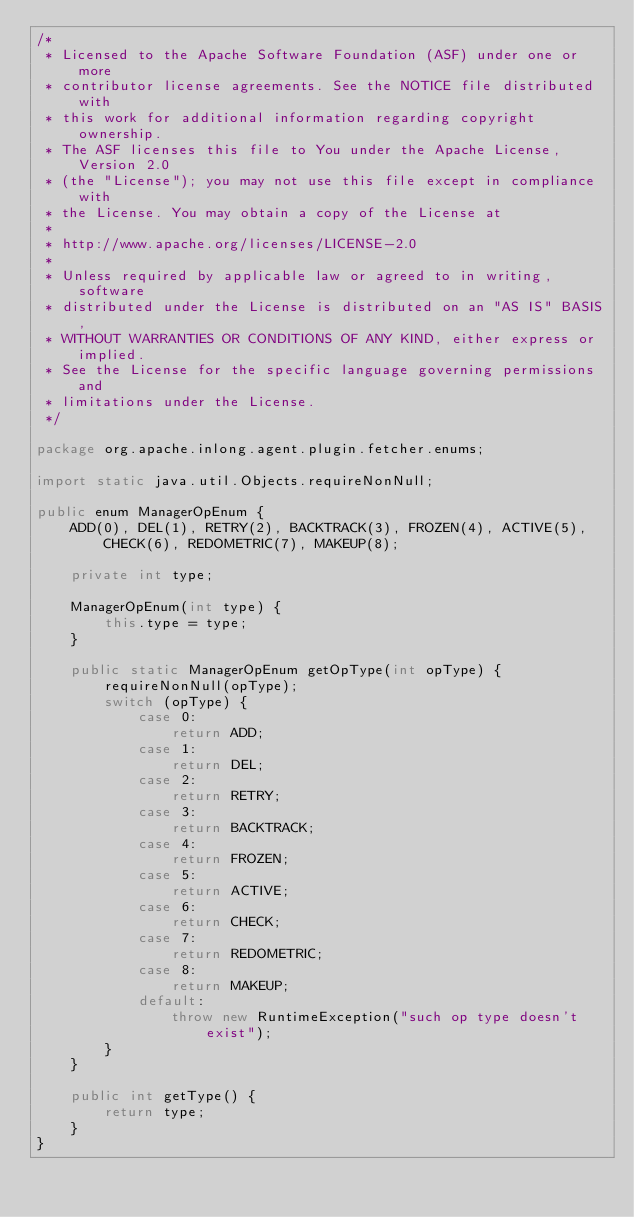Convert code to text. <code><loc_0><loc_0><loc_500><loc_500><_Java_>/*
 * Licensed to the Apache Software Foundation (ASF) under one or more
 * contributor license agreements. See the NOTICE file distributed with
 * this work for additional information regarding copyright ownership.
 * The ASF licenses this file to You under the Apache License, Version 2.0
 * (the "License"); you may not use this file except in compliance with
 * the License. You may obtain a copy of the License at
 *
 * http://www.apache.org/licenses/LICENSE-2.0
 *
 * Unless required by applicable law or agreed to in writing, software
 * distributed under the License is distributed on an "AS IS" BASIS,
 * WITHOUT WARRANTIES OR CONDITIONS OF ANY KIND, either express or implied.
 * See the License for the specific language governing permissions and
 * limitations under the License.
 */

package org.apache.inlong.agent.plugin.fetcher.enums;

import static java.util.Objects.requireNonNull;

public enum ManagerOpEnum {
    ADD(0), DEL(1), RETRY(2), BACKTRACK(3), FROZEN(4), ACTIVE(5), CHECK(6), REDOMETRIC(7), MAKEUP(8);

    private int type;

    ManagerOpEnum(int type) {
        this.type = type;
    }

    public static ManagerOpEnum getOpType(int opType) {
        requireNonNull(opType);
        switch (opType) {
            case 0:
                return ADD;
            case 1:
                return DEL;
            case 2:
                return RETRY;
            case 3:
                return BACKTRACK;
            case 4:
                return FROZEN;
            case 5:
                return ACTIVE;
            case 6:
                return CHECK;
            case 7:
                return REDOMETRIC;
            case 8:
                return MAKEUP;
            default:
                throw new RuntimeException("such op type doesn't exist");
        }
    }

    public int getType() {
        return type;
    }
}
</code> 